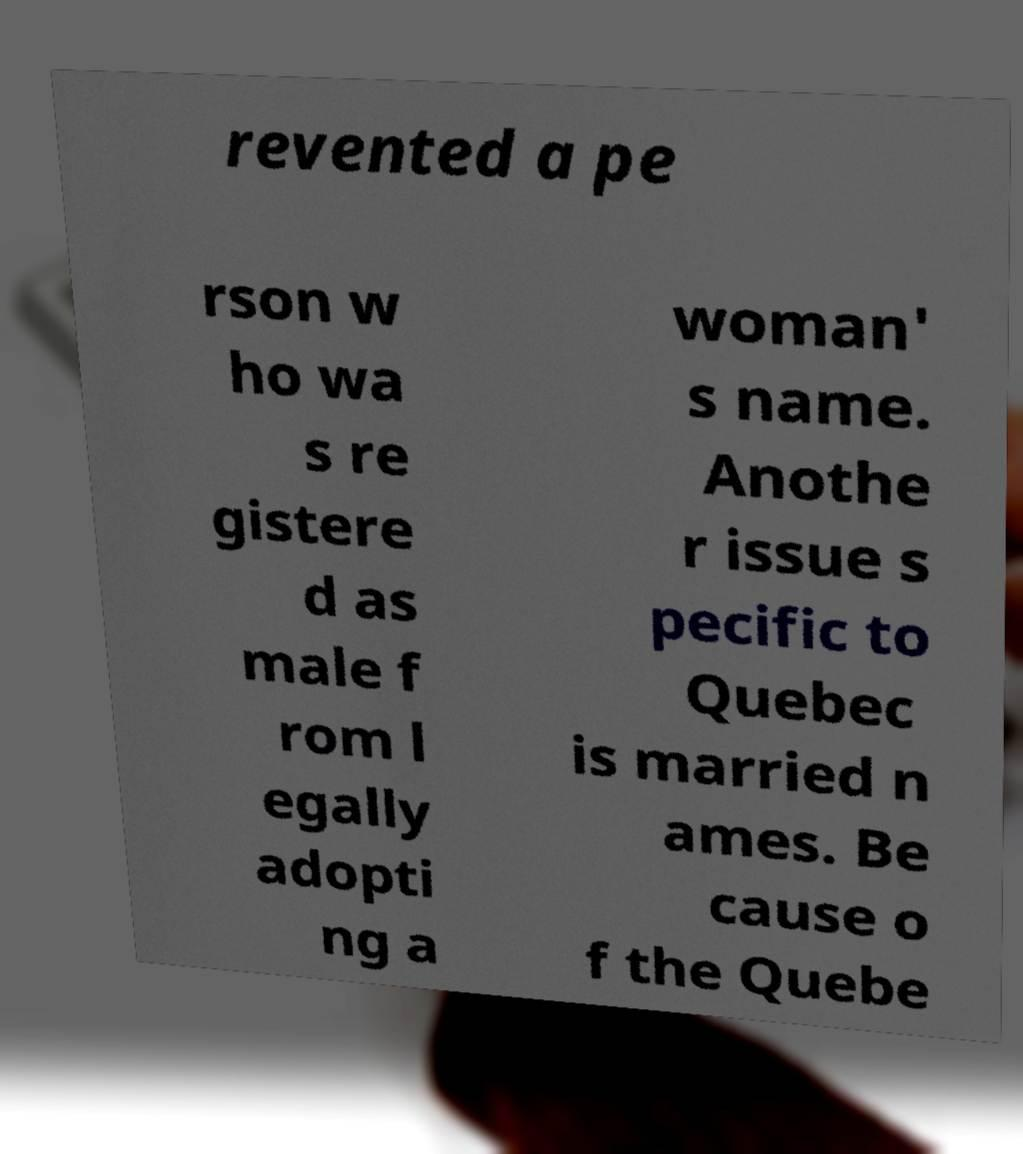What messages or text are displayed in this image? I need them in a readable, typed format. revented a pe rson w ho wa s re gistere d as male f rom l egally adopti ng a woman' s name. Anothe r issue s pecific to Quebec is married n ames. Be cause o f the Quebe 